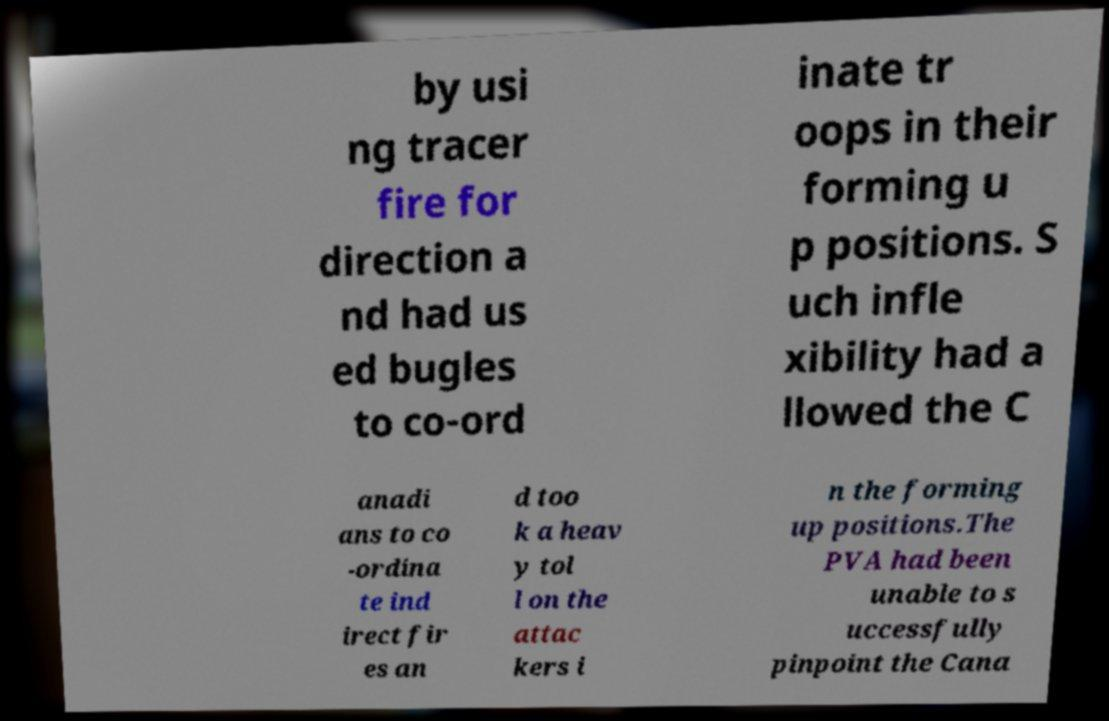Please identify and transcribe the text found in this image. by usi ng tracer fire for direction a nd had us ed bugles to co-ord inate tr oops in their forming u p positions. S uch infle xibility had a llowed the C anadi ans to co -ordina te ind irect fir es an d too k a heav y tol l on the attac kers i n the forming up positions.The PVA had been unable to s uccessfully pinpoint the Cana 